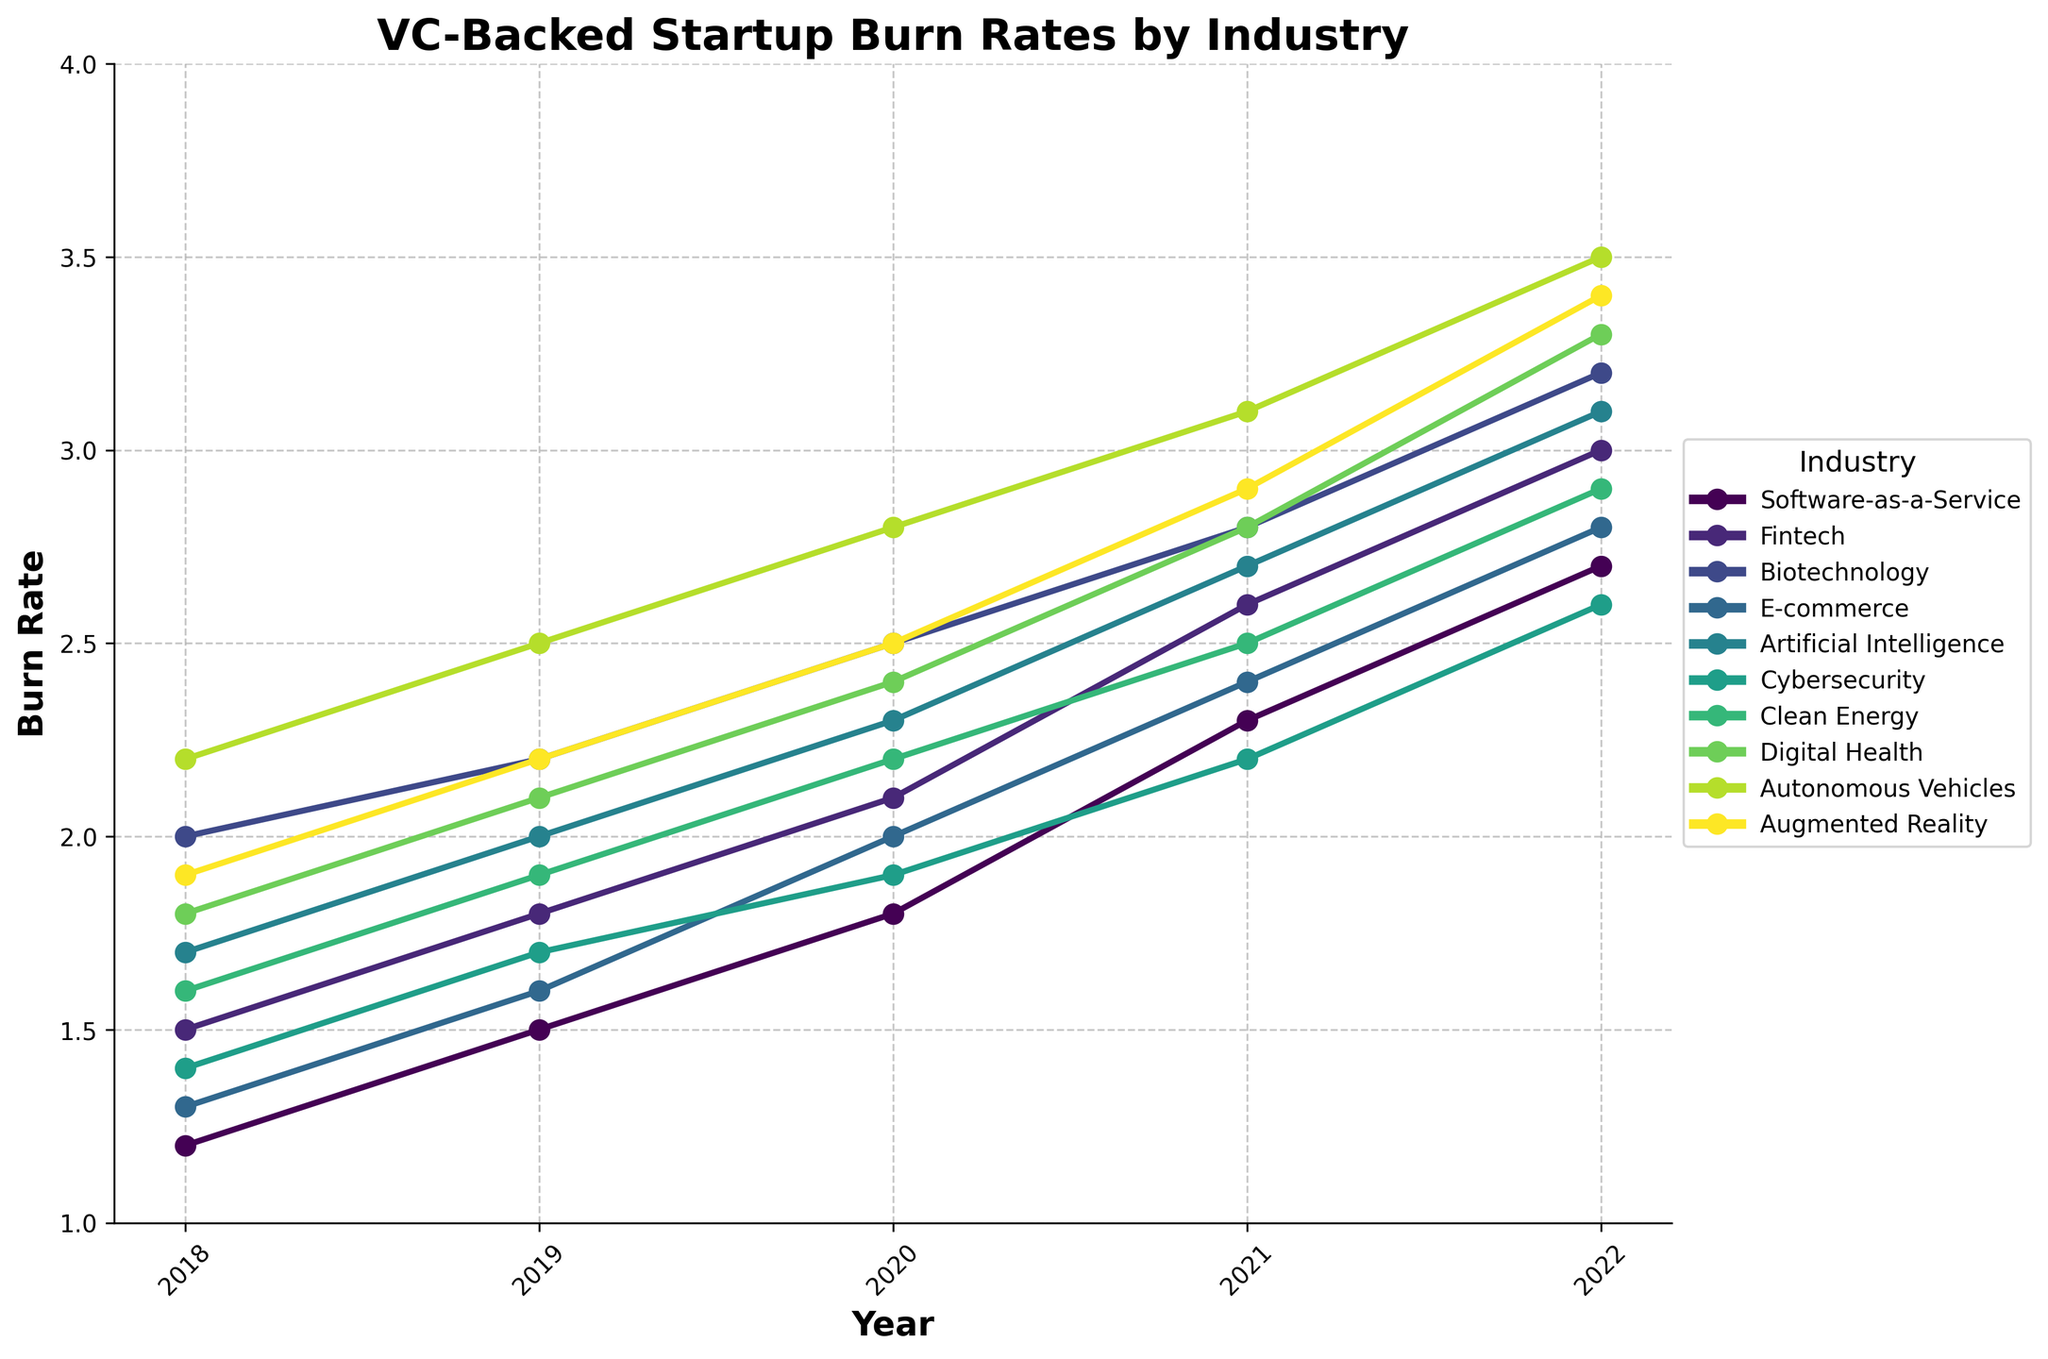What was the burn rate for Autonomous Vehicles in 2019? Look at the trend line and color corresponding to Autonomous Vehicles, follow the markers to the year 2019, and check the burn rate.
Answer: 2.5 Which industry had the highest burn rate in 2022? Identify all the industry lines and markers at the point corresponding to the year 2022, and find the one with the highest y-coordinate.
Answer: Autonomous Vehicles Compare the burn rate trends of Fintech and E-commerce from 2018 to 2022. Which industry had a more significant increase? Calculate the burn rate increase for both industries from 2018 to 2022. Fintech goes from 1.5 to 3.0 (increase of 1.5), and E-commerce goes from 1.3 to 2.8 (increase of 1.5).
Answer: Both had equal increases What is the average burn rate across all industries in 2021? Add up the burn rates for all industries in 2021 (2.3 + 2.6 + 2.8 + 2.4 + 2.7 + 2.2 + 2.5 + 2.8 + 3.1 + 2.9), then divide by the number of industries (10).
Answer: 2.63 Which industry had the steepest increase in burn rate between 2020 and 2021? Calculate the difference in burn rates for each industry between 2020 and 2021. The differences are: SaaS (0.5), Fintech (0.5), Biotechnology (0.3), E-commerce (0.4), AI (0.4), Cybersecurity (0.3), Clean Energy (0.3), Digital Health (0.4), Autonomous Vehicles (0.3), AR (0.4).
Answer: SaaS and Fintech had the steepest increase What is the visual trend of the burn rate for Software-as-a-Service from 2018 to 2022? Observe the line representing SaaS from 2018 to 2022, which shows a general upward trend with increasing heights each year.
Answer: Increasing trend In 2020, which industry had a burn rate equal to 2.5 and which industries were below this level? Identify the marker heights at 2.5 for 2020, and check which industry corresponds. Also, list industries with burn rates below 2.5.
Answer: Biotechnology at 2.5. SaaS, Fintech, E-commerce, AI, Cybersecurity, Clean Energy are below 2.5 How does the 2022 burn rate of Digital Health compare to that of Clean Energy? Compare the 2022 marker heights of Digital Health and Clean Energy. Digital Health at 3.3 and Clean Energy at 2.9.
Answer: Digital Health is higher What is the range of burn rates for Augmented Reality from 2018 to 2022? Find the minimum and maximum burn rates for Augmented Reality from 2018 to 2022, which are 1.9 and 3.4 respectively. Then subtract the minimum from the maximum.
Answer: 1.5 